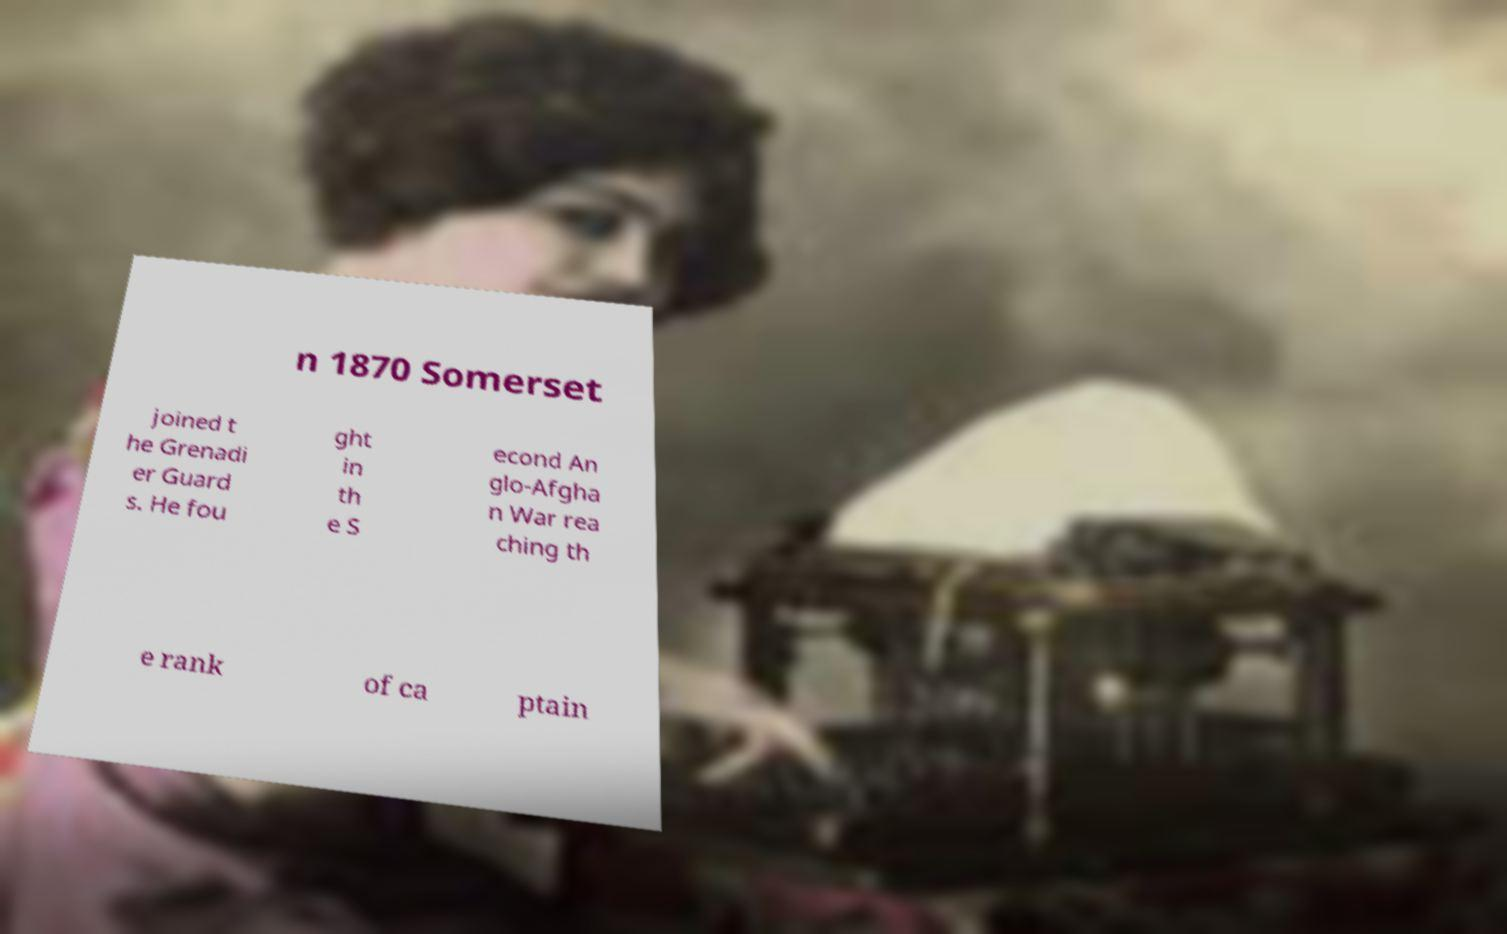Can you accurately transcribe the text from the provided image for me? n 1870 Somerset joined t he Grenadi er Guard s. He fou ght in th e S econd An glo-Afgha n War rea ching th e rank of ca ptain 